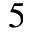<formula> <loc_0><loc_0><loc_500><loc_500>5</formula> 